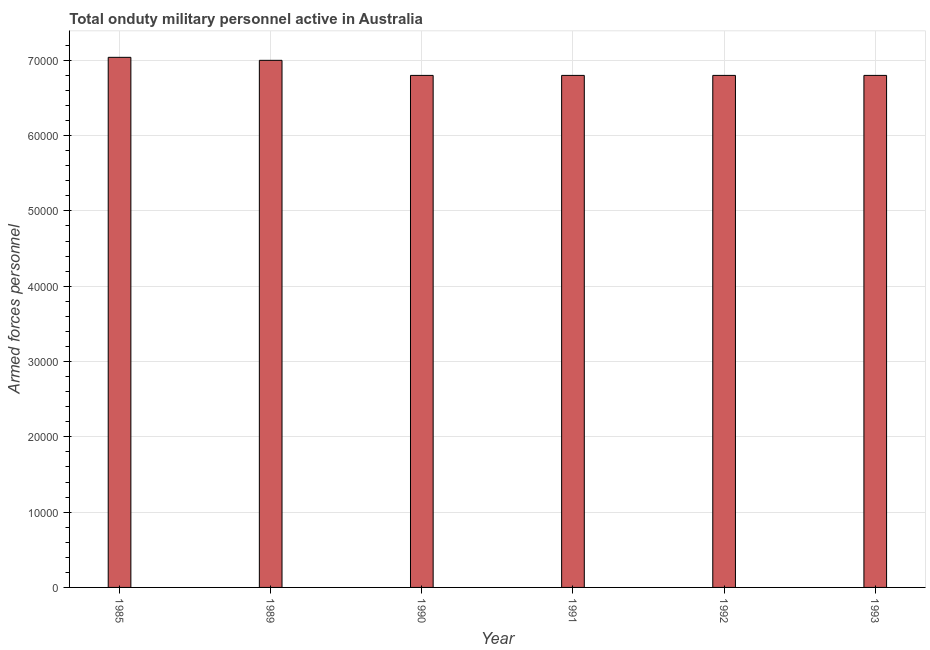Does the graph contain any zero values?
Offer a very short reply. No. What is the title of the graph?
Your answer should be very brief. Total onduty military personnel active in Australia. What is the label or title of the Y-axis?
Keep it short and to the point. Armed forces personnel. What is the number of armed forces personnel in 1993?
Your response must be concise. 6.80e+04. Across all years, what is the maximum number of armed forces personnel?
Your answer should be compact. 7.04e+04. Across all years, what is the minimum number of armed forces personnel?
Make the answer very short. 6.80e+04. In which year was the number of armed forces personnel maximum?
Offer a terse response. 1985. What is the sum of the number of armed forces personnel?
Provide a succinct answer. 4.12e+05. What is the difference between the number of armed forces personnel in 1985 and 1991?
Make the answer very short. 2400. What is the average number of armed forces personnel per year?
Keep it short and to the point. 6.87e+04. What is the median number of armed forces personnel?
Your answer should be compact. 6.80e+04. Do a majority of the years between 1991 and 1990 (inclusive) have number of armed forces personnel greater than 60000 ?
Provide a short and direct response. No. Is the number of armed forces personnel in 1990 less than that in 1992?
Your answer should be compact. No. What is the difference between the highest and the lowest number of armed forces personnel?
Keep it short and to the point. 2400. In how many years, is the number of armed forces personnel greater than the average number of armed forces personnel taken over all years?
Offer a terse response. 2. What is the Armed forces personnel in 1985?
Give a very brief answer. 7.04e+04. What is the Armed forces personnel of 1989?
Your answer should be compact. 7.00e+04. What is the Armed forces personnel of 1990?
Your answer should be compact. 6.80e+04. What is the Armed forces personnel of 1991?
Give a very brief answer. 6.80e+04. What is the Armed forces personnel of 1992?
Your response must be concise. 6.80e+04. What is the Armed forces personnel in 1993?
Your answer should be compact. 6.80e+04. What is the difference between the Armed forces personnel in 1985 and 1990?
Make the answer very short. 2400. What is the difference between the Armed forces personnel in 1985 and 1991?
Provide a succinct answer. 2400. What is the difference between the Armed forces personnel in 1985 and 1992?
Your answer should be compact. 2400. What is the difference between the Armed forces personnel in 1985 and 1993?
Your answer should be compact. 2400. What is the difference between the Armed forces personnel in 1990 and 1993?
Your answer should be compact. 0. What is the difference between the Armed forces personnel in 1991 and 1992?
Provide a short and direct response. 0. What is the difference between the Armed forces personnel in 1992 and 1993?
Your answer should be very brief. 0. What is the ratio of the Armed forces personnel in 1985 to that in 1990?
Offer a very short reply. 1.03. What is the ratio of the Armed forces personnel in 1985 to that in 1991?
Offer a terse response. 1.03. What is the ratio of the Armed forces personnel in 1985 to that in 1992?
Your answer should be compact. 1.03. What is the ratio of the Armed forces personnel in 1985 to that in 1993?
Make the answer very short. 1.03. What is the ratio of the Armed forces personnel in 1989 to that in 1991?
Your response must be concise. 1.03. What is the ratio of the Armed forces personnel in 1989 to that in 1992?
Your response must be concise. 1.03. What is the ratio of the Armed forces personnel in 1989 to that in 1993?
Offer a very short reply. 1.03. What is the ratio of the Armed forces personnel in 1990 to that in 1991?
Keep it short and to the point. 1. What is the ratio of the Armed forces personnel in 1990 to that in 1993?
Make the answer very short. 1. What is the ratio of the Armed forces personnel in 1991 to that in 1992?
Your response must be concise. 1. 